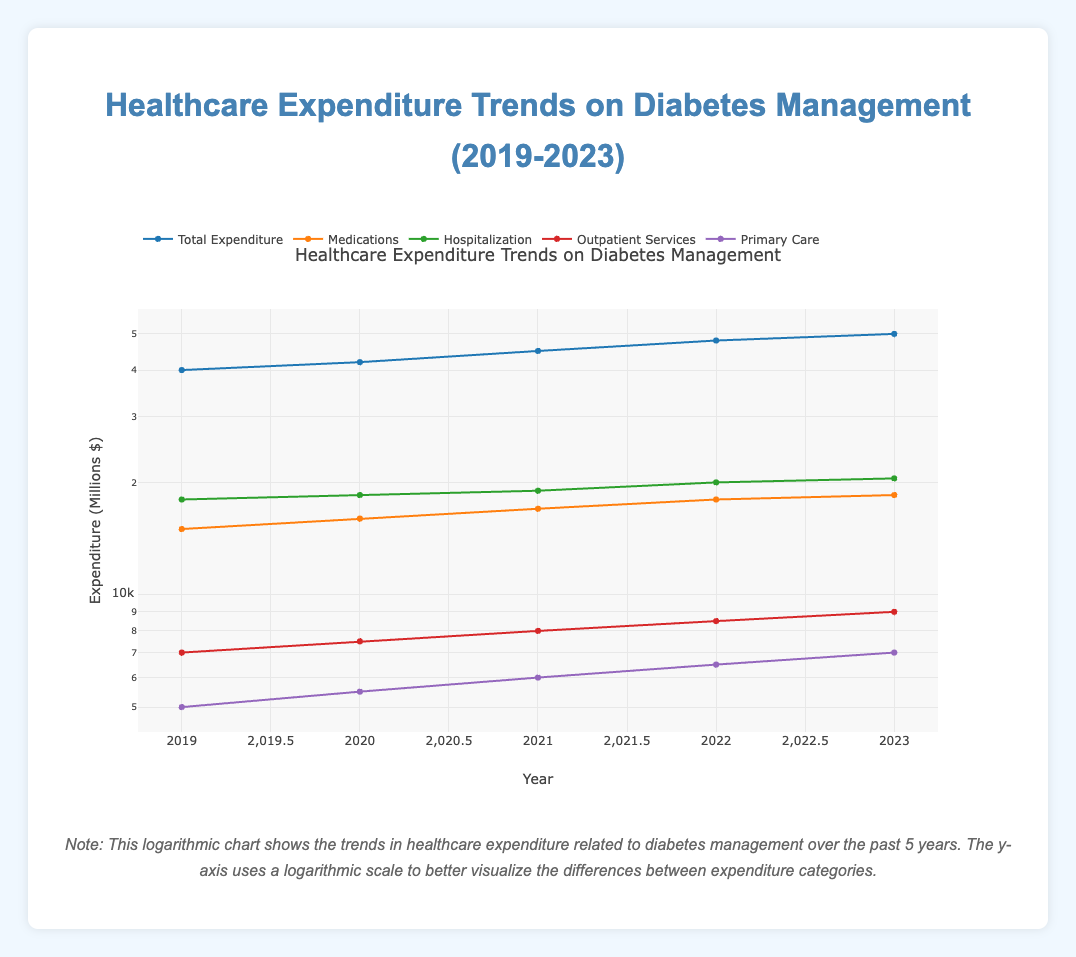What was the total healthcare expenditure in 2020? The table indicates that in 2020, the total expenditure was 42,000 million dollars.
Answer: 42,000 million What was the yearly increase in total expenditure from 2019 to 2020? The total expenditure in 2019 was 40,000 million and in 2020 it was 42,000 million. The increase is 42,000 - 40,000 = 2,000 million.
Answer: 2,000 million Did medications expenditure increase every year from 2019 to 2023? By checking the medications expenditure for each year: 15,000 (2019), 16,000 (2020), 17,000 (2021), 18,000 (2022), and 18,500 (2023), it is confirmed that medications expenditure increased each year.
Answer: Yes What is the total expenditure for the years 2021 and 2022 combined? The total expenditure for 2021 is 45,000 million and for 2022 it is 48,000 million. Adding them together gives 45,000 + 48,000 = 93,000 million.
Answer: 93,000 million Was the hospitalization expenditure higher than the outpatient services expenditure in all years? The hospitalization expenditure for each year is as follows: 18,000 (2019), 18,500 (2020), 19,000 (2021), 20,000 (2022), and 20,500 (2023). The outpatient services expenditure for the same years is 7,000, 7,500, 8,000, 8,500, and 9,000 respectively. In each year, hospitalization expenditure was greater than outpatient services expenditure.
Answer: Yes What was the average primary care expenditure over the five years? Summing the primary care expenditures gives 5,000 (2019) + 5,500 (2020) + 6,000 (2021) + 6,500 (2022) + 7,000 (2023) = 30,000 million. There are 5 years, so the average is 30,000 / 5 = 6,000 million.
Answer: 6,000 million In which year did the outpatient services expenditure show the highest value? The outpatient services expenditures over the years are: 7,000 (2019), 7,500 (2020), 8,000 (2021), 8,500 (2022), and 9,000 (2023). The highest value occurs in 2023.
Answer: 2023 What is the difference in total expenditure between the years 2019 and 2023? The total expenditure in 2019 is 40,000 million, and in 2023 it is 50,000 million. The difference is 50,000 - 40,000 = 10,000 million.
Answer: 10,000 million 